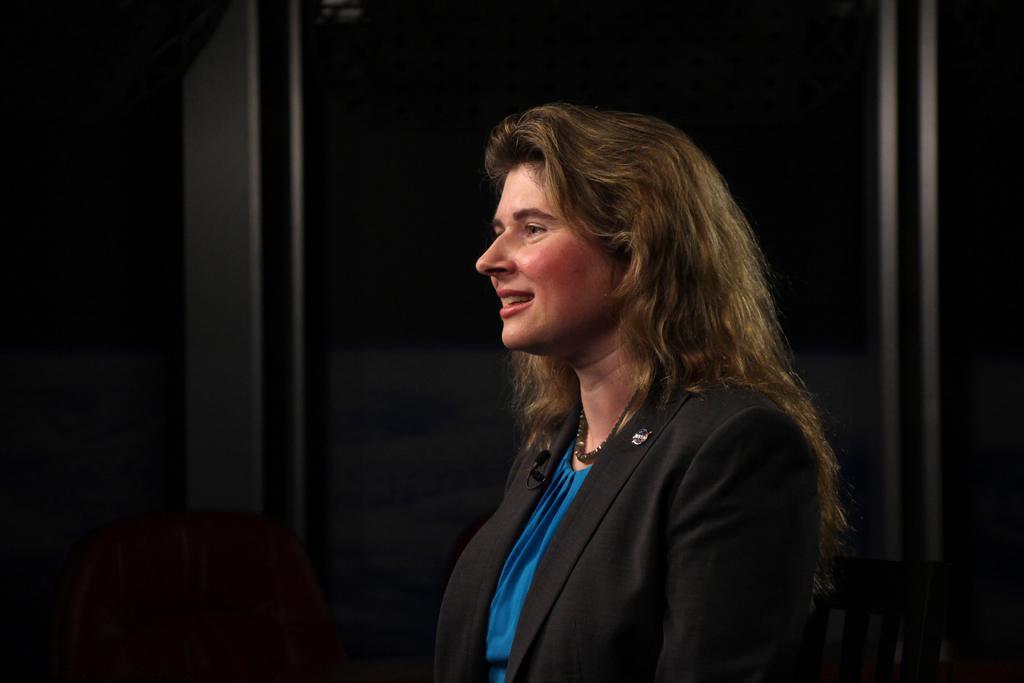Please provide a concise description of this image. In the front of the image I can see a woman and chairs. In the background of the image it is dark. 